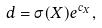Convert formula to latex. <formula><loc_0><loc_0><loc_500><loc_500>d = \sigma ( X ) e ^ { c _ { X } } ,</formula> 